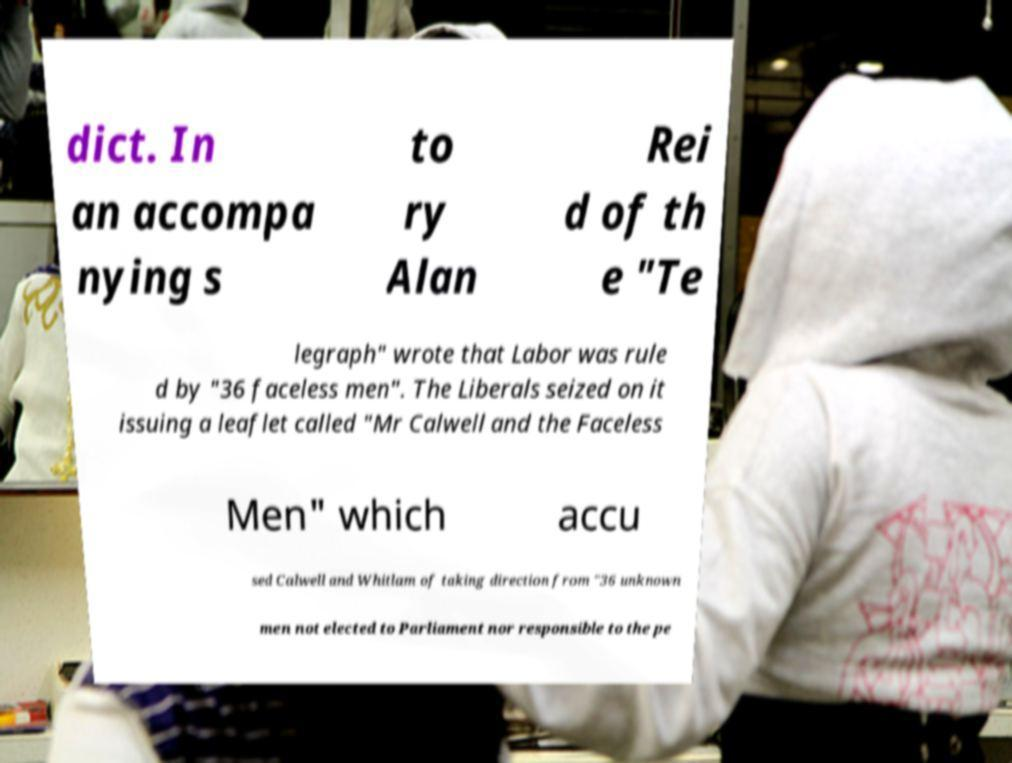There's text embedded in this image that I need extracted. Can you transcribe it verbatim? dict. In an accompa nying s to ry Alan Rei d of th e "Te legraph" wrote that Labor was rule d by "36 faceless men". The Liberals seized on it issuing a leaflet called "Mr Calwell and the Faceless Men" which accu sed Calwell and Whitlam of taking direction from "36 unknown men not elected to Parliament nor responsible to the pe 